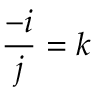<formula> <loc_0><loc_0><loc_500><loc_500>{ \frac { - i } { j } } = k</formula> 